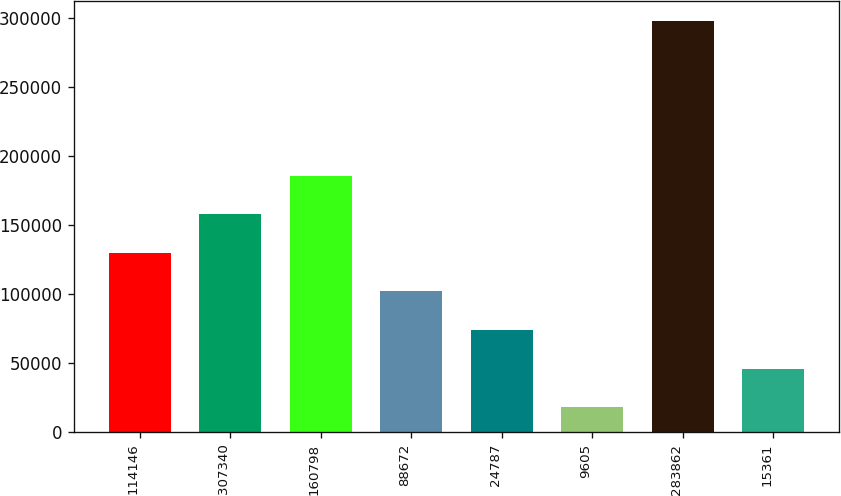Convert chart. <chart><loc_0><loc_0><loc_500><loc_500><bar_chart><fcel>114146<fcel>307340<fcel>160798<fcel>88672<fcel>24787<fcel>9605<fcel>283862<fcel>15361<nl><fcel>129828<fcel>157792<fcel>185756<fcel>101864<fcel>73900.6<fcel>17973<fcel>297611<fcel>45936.8<nl></chart> 